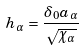Convert formula to latex. <formula><loc_0><loc_0><loc_500><loc_500>h _ { \alpha } = \frac { \delta _ { 0 } a _ { \alpha } } { \sqrt { \chi _ { \alpha } } }</formula> 